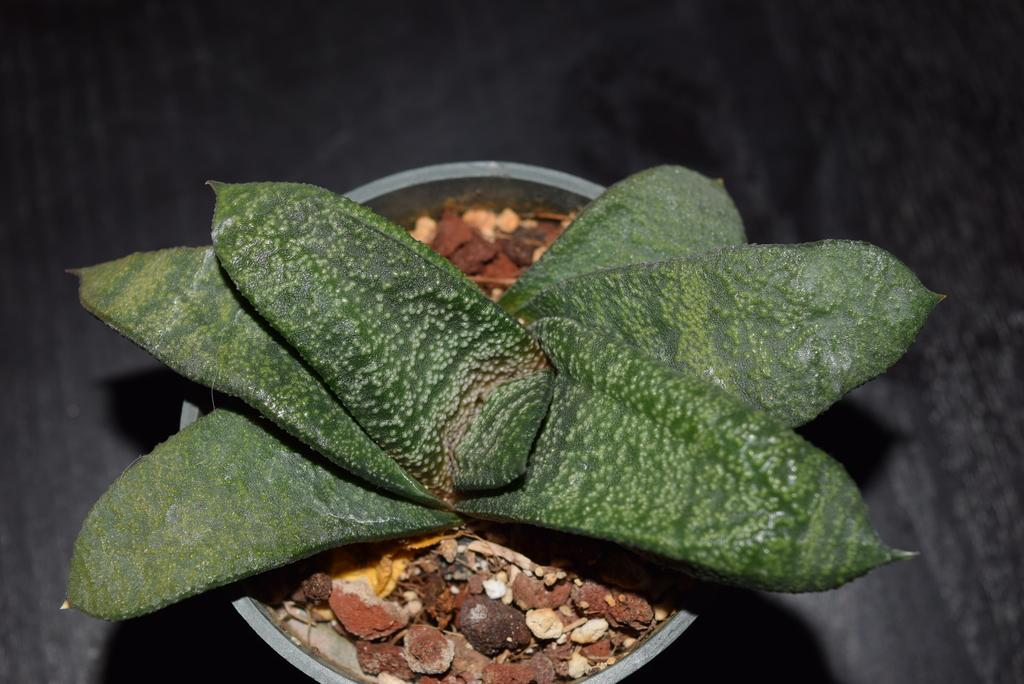What is the main subject of the image? There is a plant in the image. What color is the background of the image? The background of the image is black. What type of gate can be seen in the image? There is no gate present in the image. How many parts does the plant have in the image? The number of parts of the plant cannot be determined from the image alone, as it does not provide enough detail. 